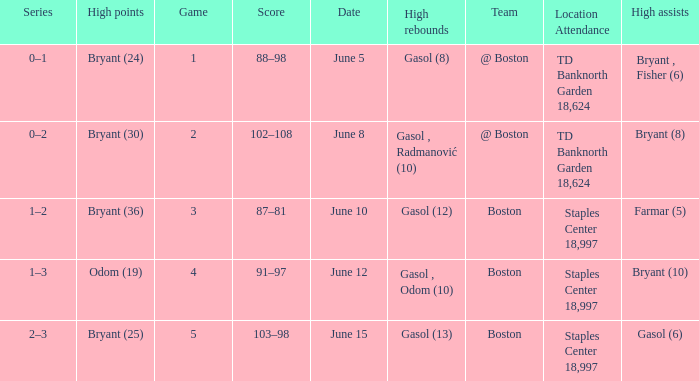Name the number of games on june 12 1.0. 